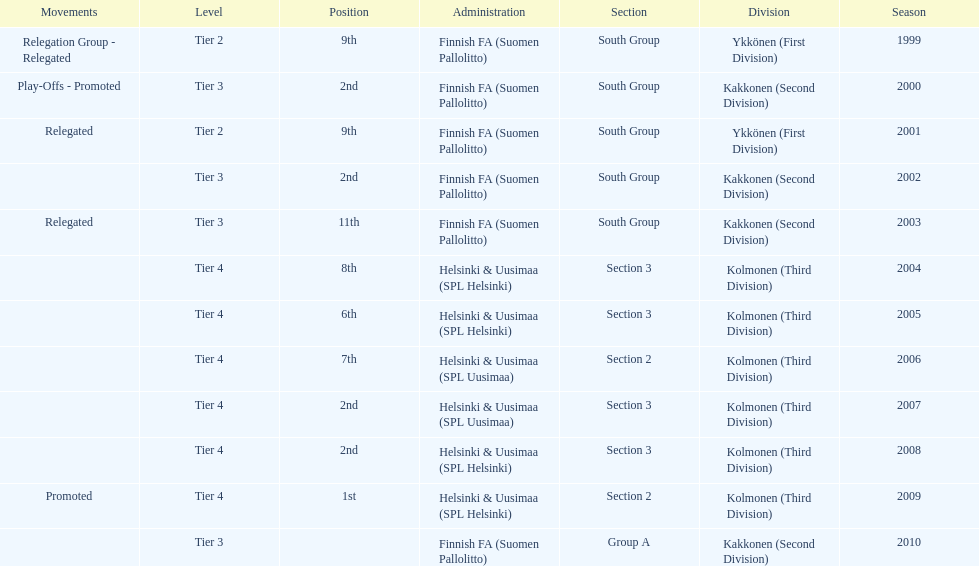Within the third partition, how many existed in division 3? 4. 